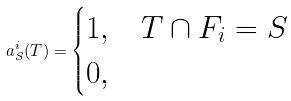<formula> <loc_0><loc_0><loc_500><loc_500>a ^ { i } _ { S } ( T ) = \begin{cases} 1 , & T \cap F _ { i } = S \\ 0 , & \end{cases}</formula> 